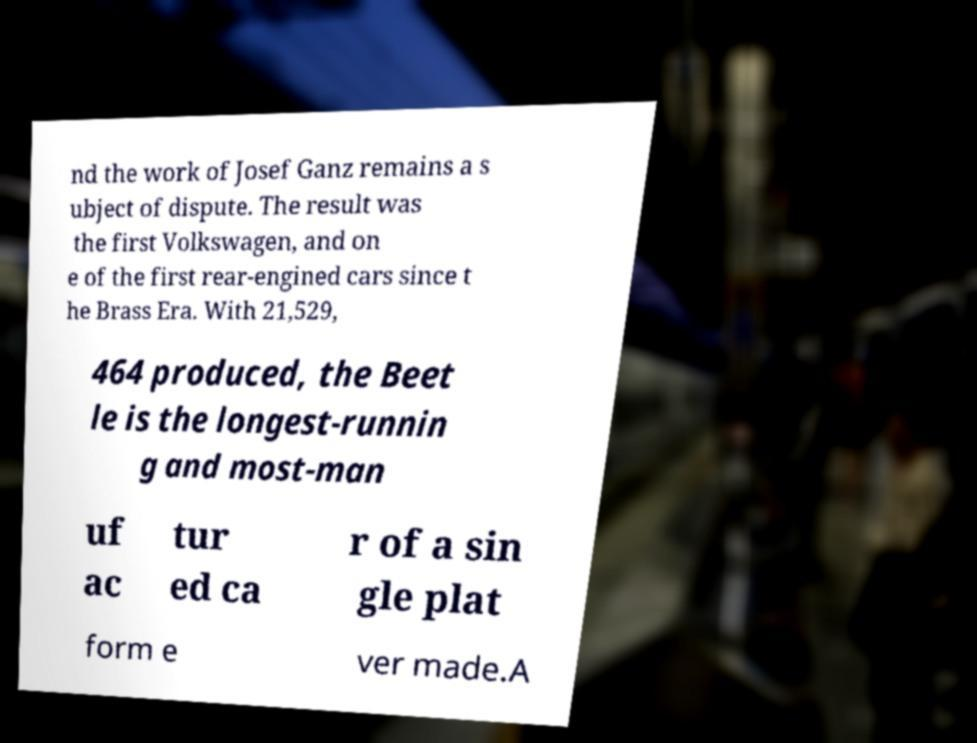Please identify and transcribe the text found in this image. nd the work of Josef Ganz remains a s ubject of dispute. The result was the first Volkswagen, and on e of the first rear-engined cars since t he Brass Era. With 21,529, 464 produced, the Beet le is the longest-runnin g and most-man uf ac tur ed ca r of a sin gle plat form e ver made.A 